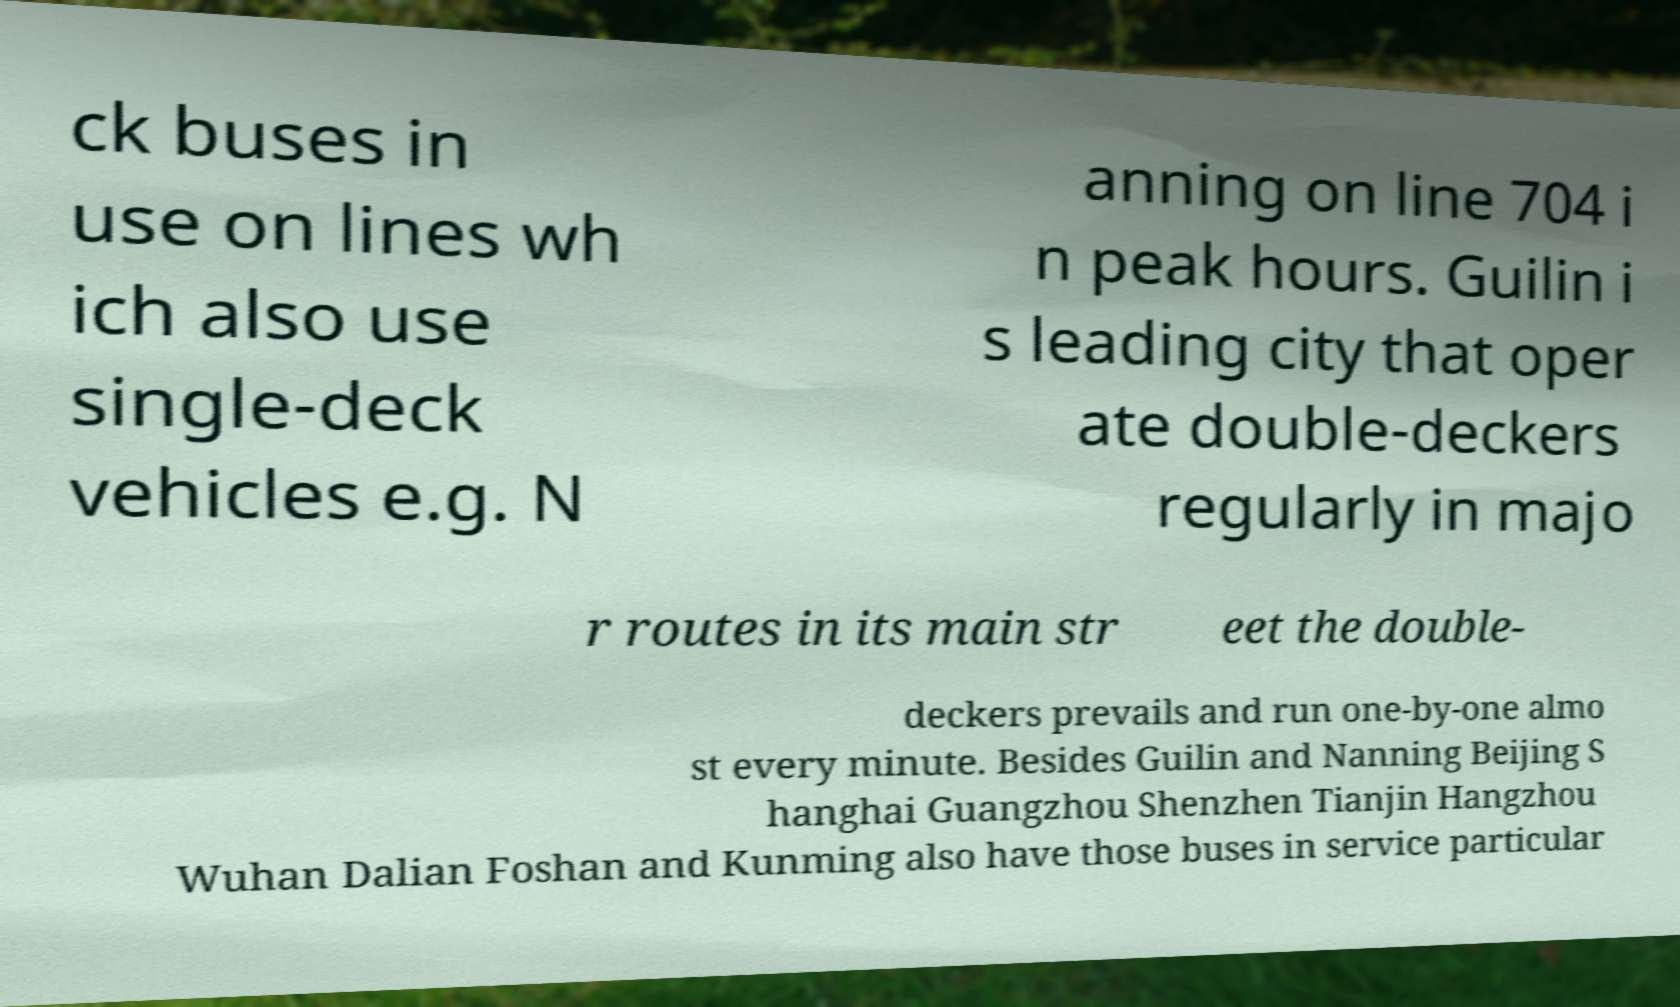I need the written content from this picture converted into text. Can you do that? ck buses in use on lines wh ich also use single-deck vehicles e.g. N anning on line 704 i n peak hours. Guilin i s leading city that oper ate double-deckers regularly in majo r routes in its main str eet the double- deckers prevails and run one-by-one almo st every minute. Besides Guilin and Nanning Beijing S hanghai Guangzhou Shenzhen Tianjin Hangzhou Wuhan Dalian Foshan and Kunming also have those buses in service particular 